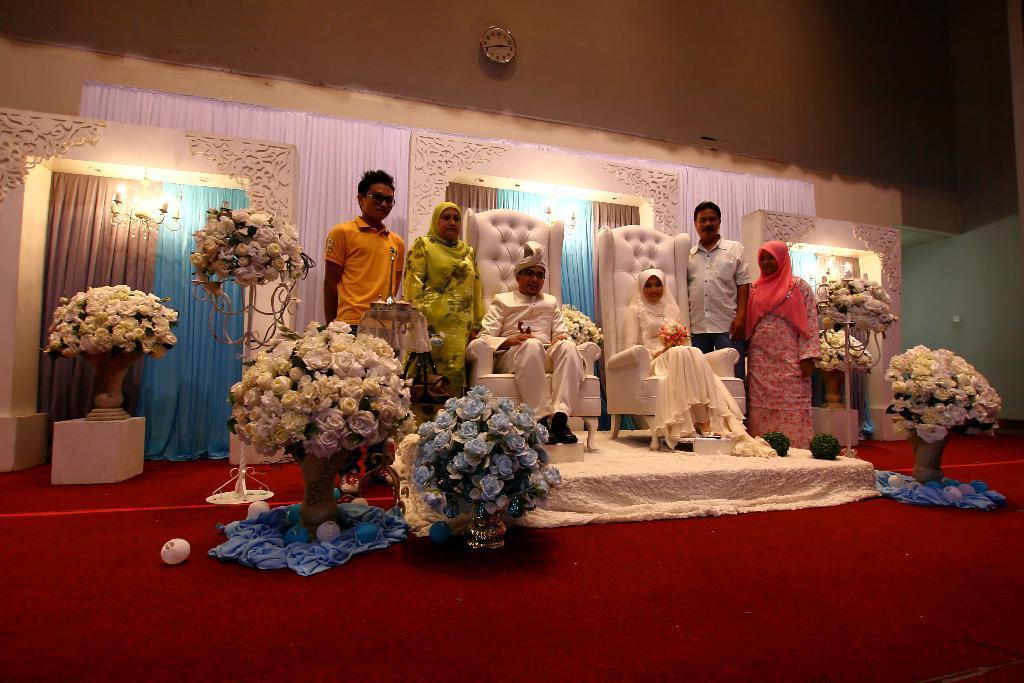Please provide a concise description of this image. In this picture I can see two persons sitting on the chairs, there are four persons standing, there are chandeliers, flower vases, there are wedding arches, and there is a clock attached to the wall. 